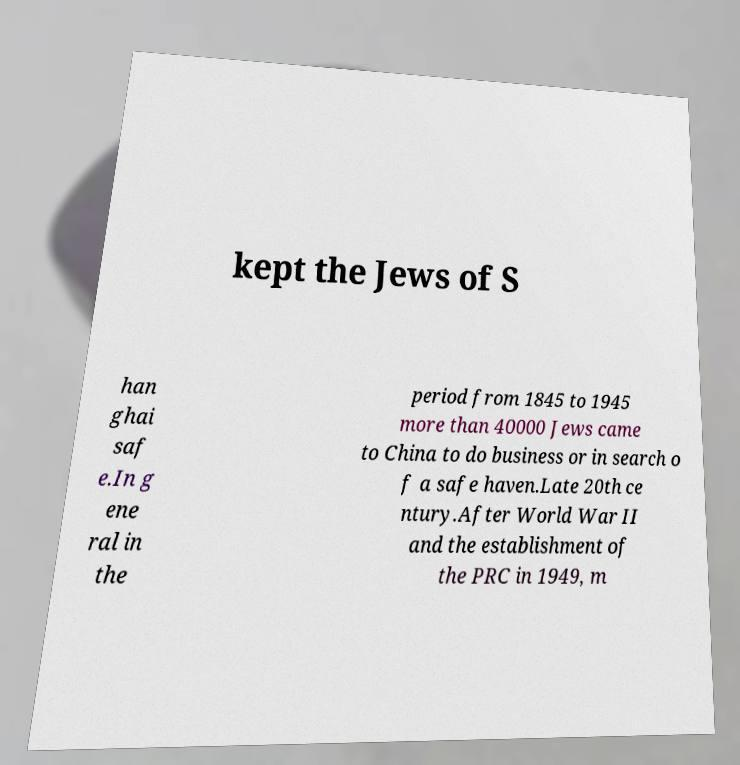There's text embedded in this image that I need extracted. Can you transcribe it verbatim? kept the Jews of S han ghai saf e.In g ene ral in the period from 1845 to 1945 more than 40000 Jews came to China to do business or in search o f a safe haven.Late 20th ce ntury.After World War II and the establishment of the PRC in 1949, m 